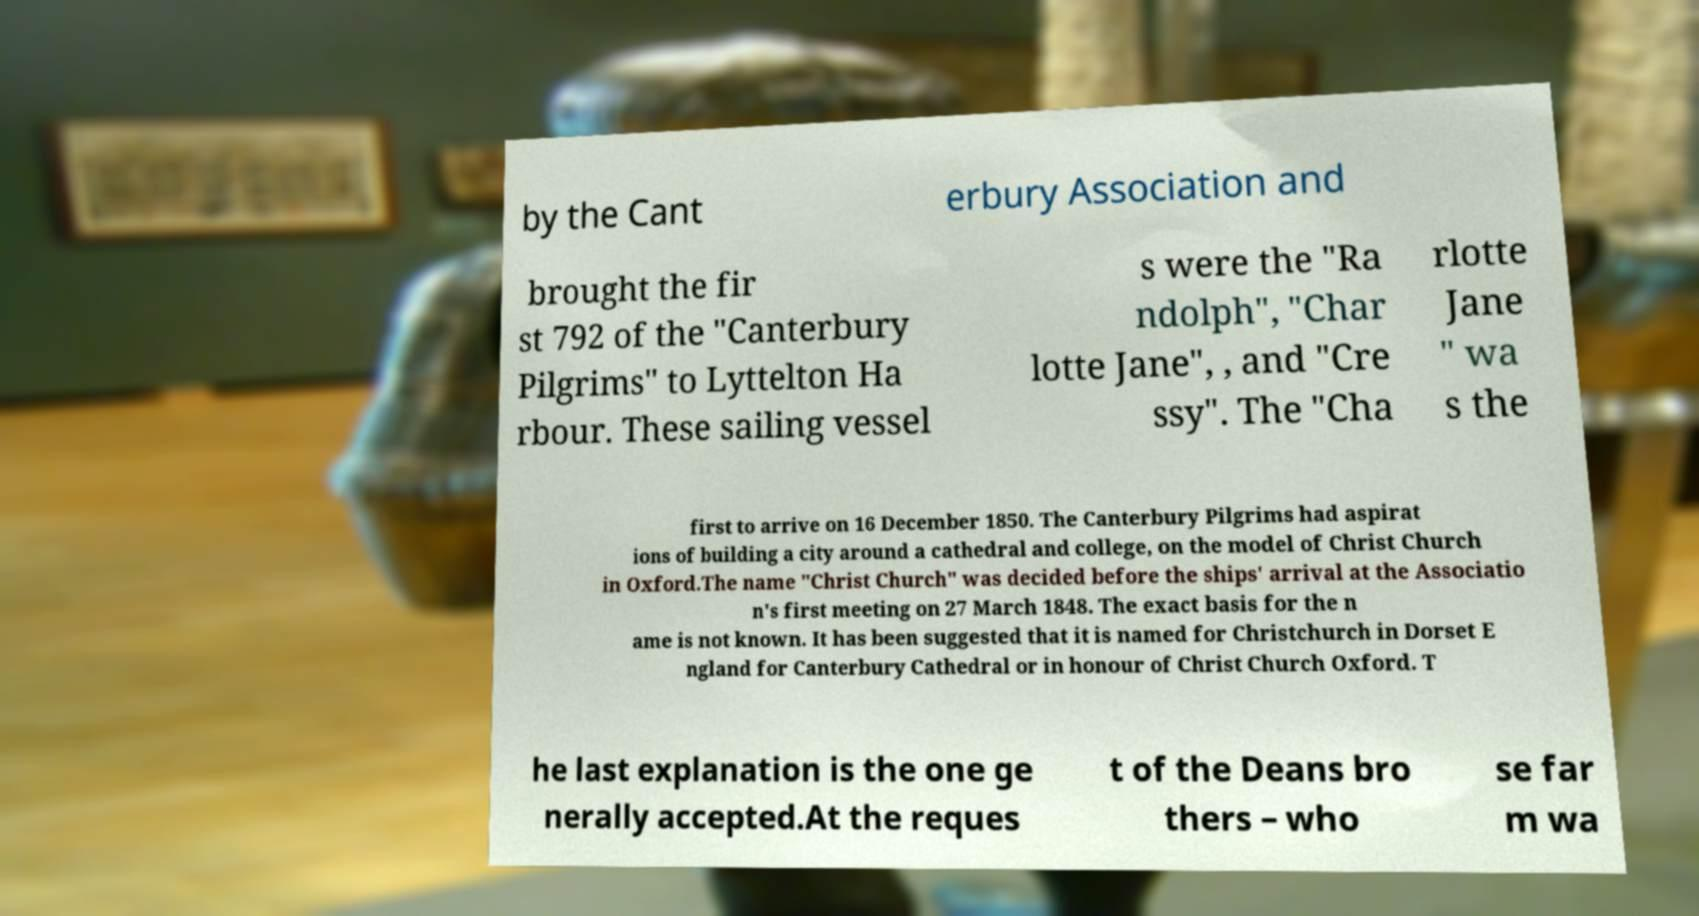Please identify and transcribe the text found in this image. by the Cant erbury Association and brought the fir st 792 of the "Canterbury Pilgrims" to Lyttelton Ha rbour. These sailing vessel s were the "Ra ndolph", "Char lotte Jane", , and "Cre ssy". The "Cha rlotte Jane " wa s the first to arrive on 16 December 1850. The Canterbury Pilgrims had aspirat ions of building a city around a cathedral and college, on the model of Christ Church in Oxford.The name "Christ Church" was decided before the ships' arrival at the Associatio n's first meeting on 27 March 1848. The exact basis for the n ame is not known. It has been suggested that it is named for Christchurch in Dorset E ngland for Canterbury Cathedral or in honour of Christ Church Oxford. T he last explanation is the one ge nerally accepted.At the reques t of the Deans bro thers – who se far m wa 